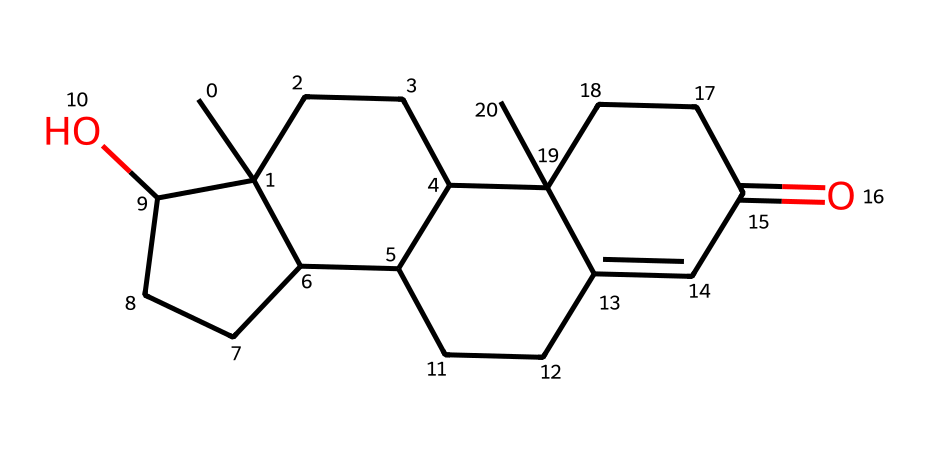What is the molecular formula of testosterone? By analyzing the chemical structure represented by the SMILES notation, we can identify the number of carbon (C), hydrogen (H), and oxygen (O) atoms present. The breakdown shows that there are 19 carbon atoms, 28 hydrogen atoms, and 2 oxygen atoms, leading to the molecular formula C19H28O2.
Answer: C19H28O2 How many rings are present in the testosterone structure? The structure exhibits a steroid backbone, characterized by multiple interconnected rings. By visually assessing the chemical structure, we can see that there are four fused rings, which is typical of steroids like testosterone.
Answer: 4 What is the role of testosterone in athletic performance? Testosterone is known to enhance muscle mass, strength, and endurance, which can lead to improved athletic performance. It interacts with muscle cells to promote protein synthesis and recovery, aiding athletes in training and competition.
Answer: muscle growth What type of hormone is testosterone classified as? Testosterone is classified as a steroid hormone, derived from cholesterol. Its structure and function align with the characteristics of steroid hormones, which include their lipid-soluble nature and ability to pass through cell membranes to influence gene expression.
Answer: steroid hormone How does testosterone affect muscle recovery? Testosterone significantly facilitates muscle recovery by increasing protein synthesis and reducing muscle breakdown after intense physical activity. This process helps athletes recover faster and return to training or competition more effectively.
Answer: increases recovery What is one impact of elevated testosterone levels on athletic performance? Elevated testosterone levels can lead to increased strength and muscle mass, which may enhance overall athletic performance and competitive edge in sports. This physiological change results from testosterone's role in stimulating muscle growth and repair.
Answer: increased strength 